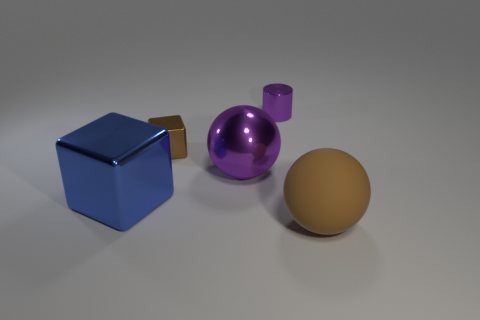Subtract 1 spheres. How many spheres are left? 1 Add 1 matte spheres. How many objects exist? 6 Subtract all cylinders. How many objects are left? 4 Subtract all green cylinders. Subtract all green cubes. How many cylinders are left? 1 Subtract all cyan cylinders. How many purple balls are left? 1 Subtract all red blocks. Subtract all small cubes. How many objects are left? 4 Add 5 brown shiny things. How many brown shiny things are left? 6 Add 3 tiny brown objects. How many tiny brown objects exist? 4 Subtract 0 red cylinders. How many objects are left? 5 